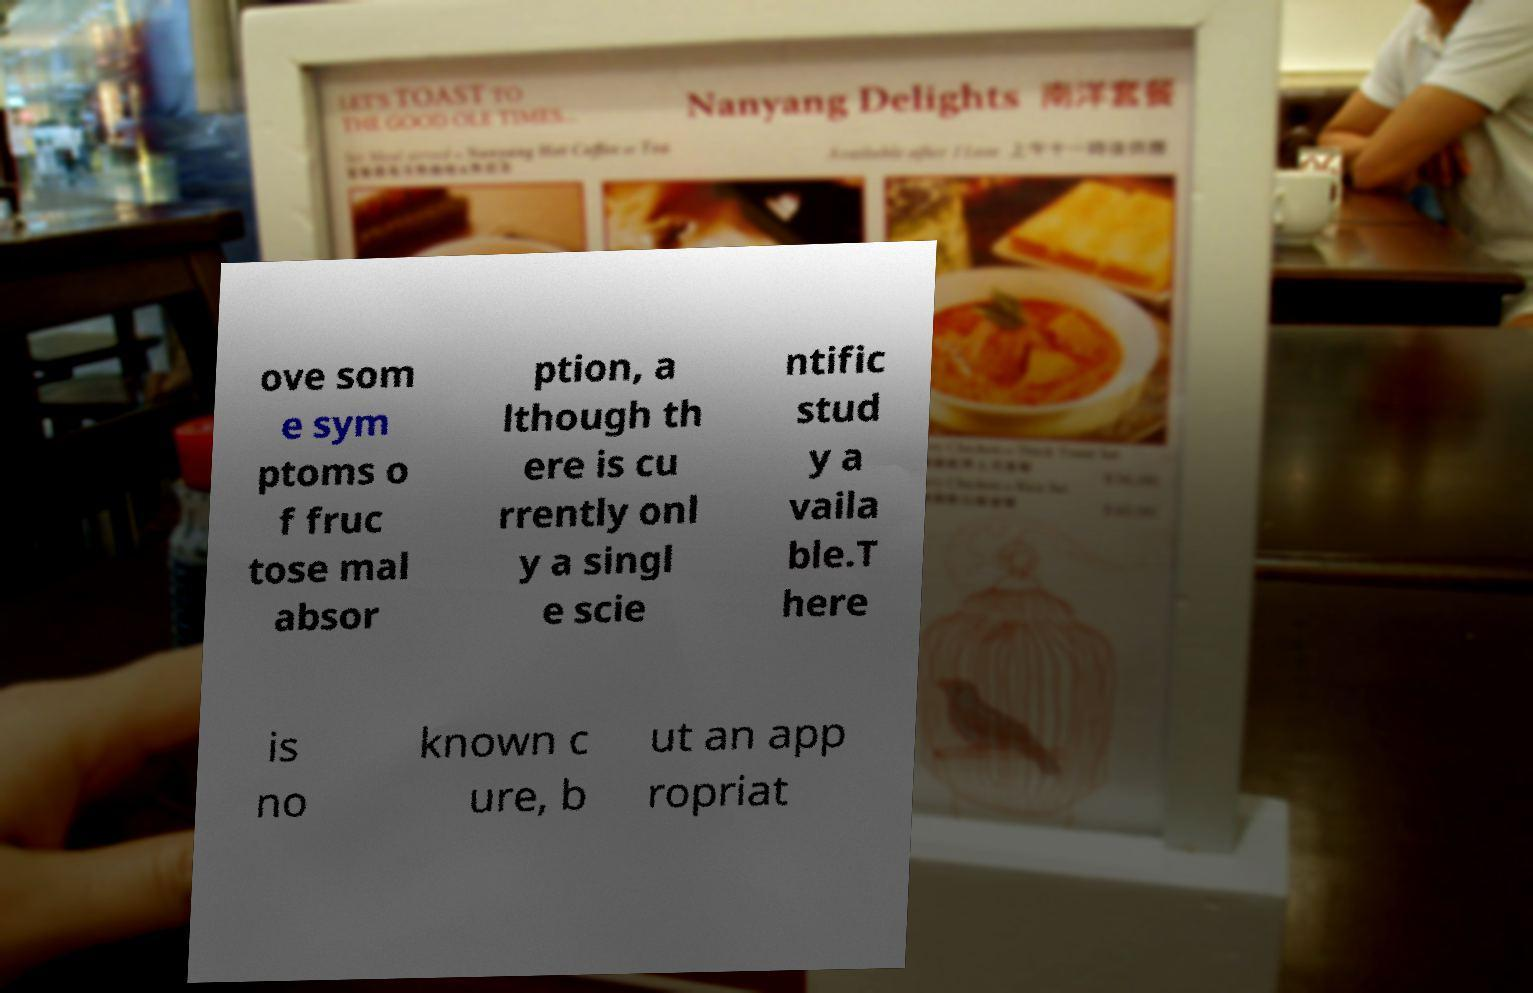Can you read and provide the text displayed in the image?This photo seems to have some interesting text. Can you extract and type it out for me? ove som e sym ptoms o f fruc tose mal absor ption, a lthough th ere is cu rrently onl y a singl e scie ntific stud y a vaila ble.T here is no known c ure, b ut an app ropriat 